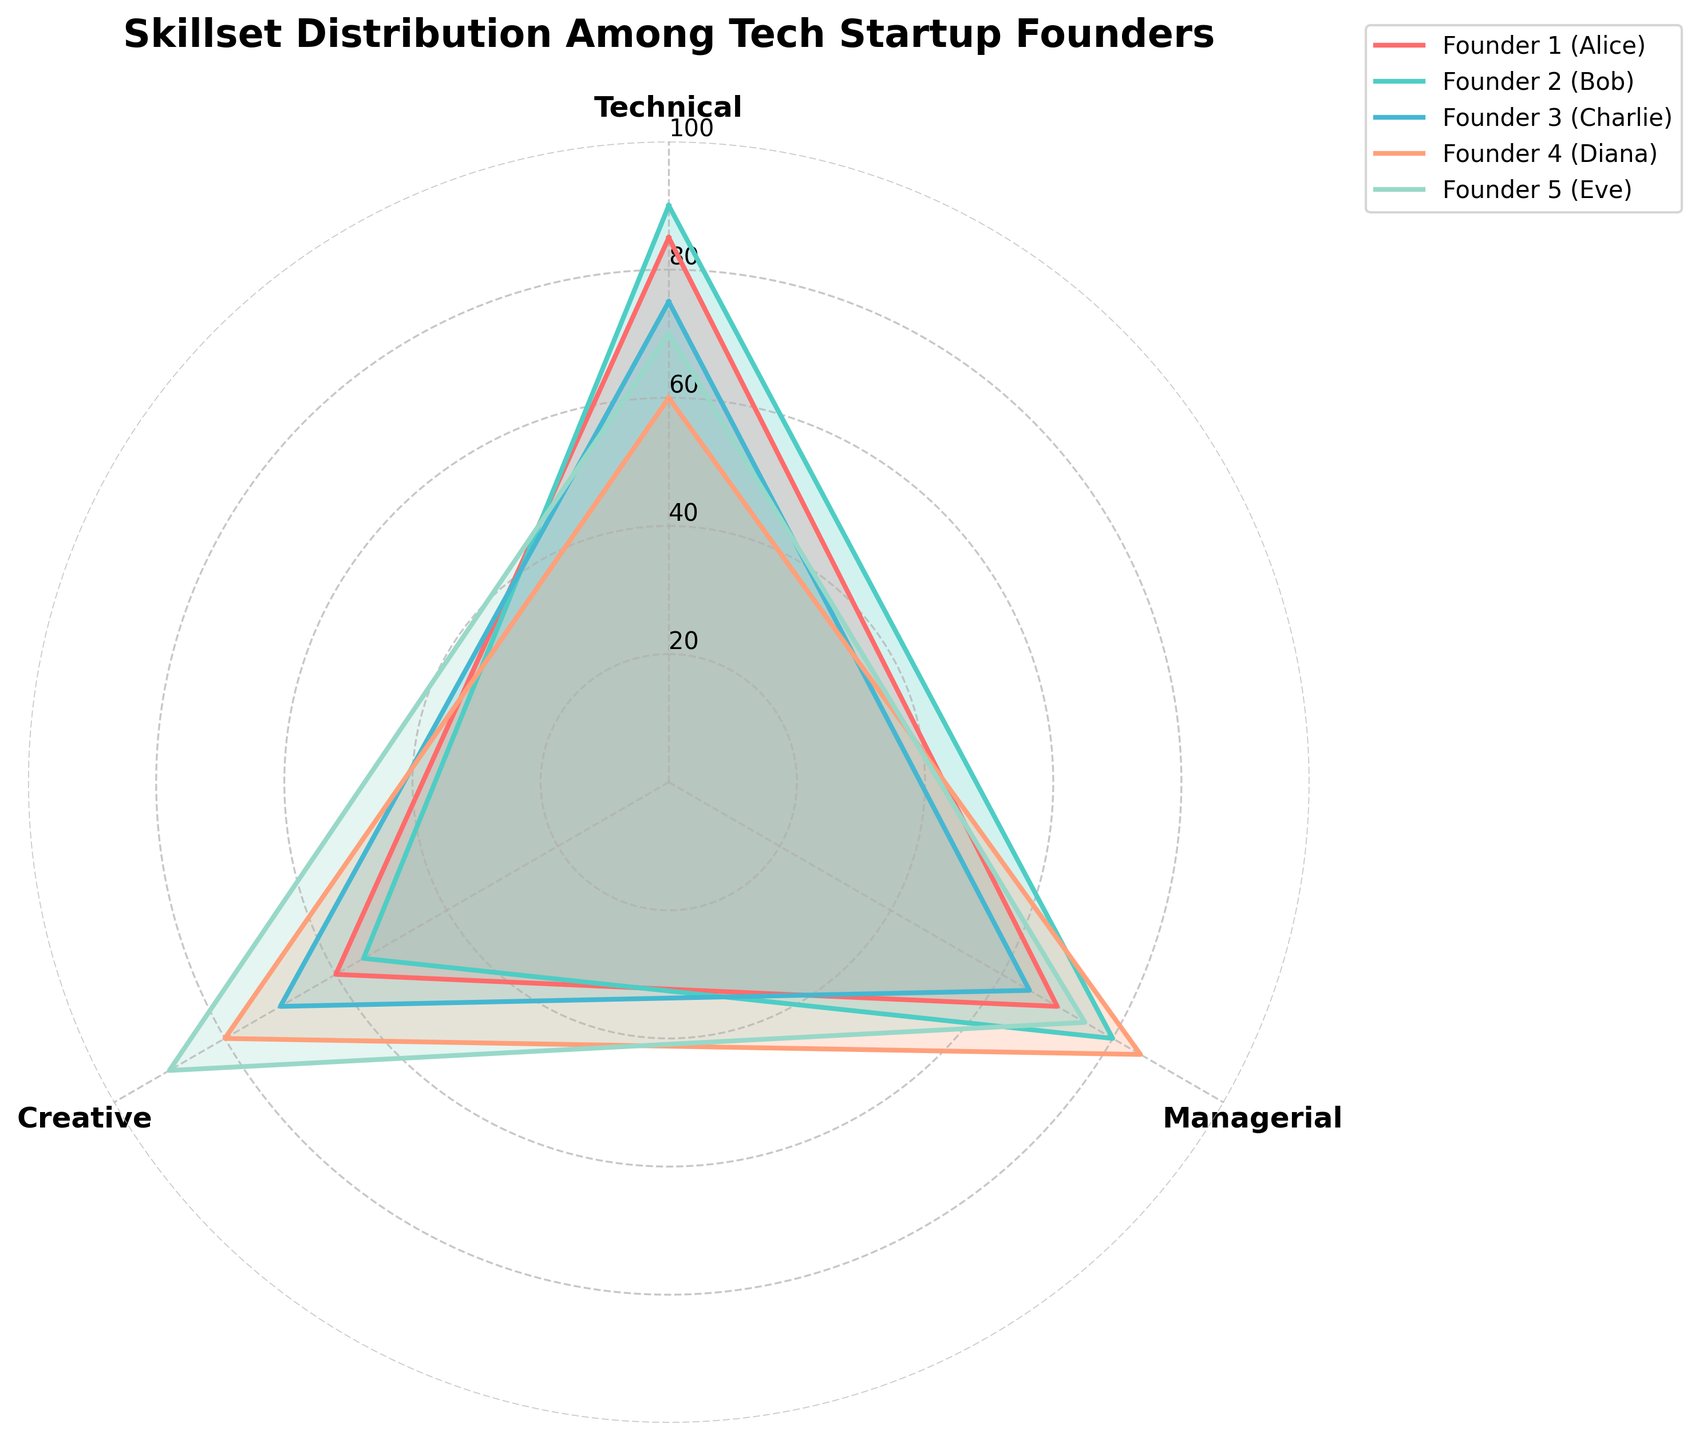What is the title of the radar chart? The title is usually prominently displayed at the top of the chart and serves as a summary of what the visualization is about. In this case, the title is "Skillset Distribution Among Tech Startup Founders".
Answer: Skillset Distribution Among Tech Startup Founders Which founder has the highest technical skill? By comparing the values in the "Technical" category for each founder, we find that Bob has the highest technical score with a value of 90.
Answer: Bob How many categories are being compared in the radar chart? The radar chart compares the founders' skill sets in three categories, which can be identified as Technical, Managerial, and Creative.
Answer: 3 Which founder has the highest managerial skills? By looking at the Managerial scores for each founder, Diana has the highest score with a value of 85.
Answer: Diana What is the average technical skill score of all founders? To find the average, sum the technical scores of all founders (85 + 90 + 75 + 60 + 70) = 380, then divide by the number of founders (5). The average is 380 / 5 = 76.
Answer: 76 Which founder has the highest average skill across all categories? Calculate the average skill score for each founder across all categories: 
Alice = (85 + 70 + 60) / 3 = 71.7, 
Bob = (90 + 80 + 55) / 3 = 75, 
Charlie = (75 + 65 + 70) / 3 = 70, 
Diana = (60 + 85 + 80) / 3 = 75, 
Eve = (70 + 75 + 90) / 3 = 78.3. 
Eve has the highest average skill score.
Answer: Eve Who has a greater creative skill, Alice or Eve? Comparing the Creative scores, Alice has 60, and Eve has 90. Thus, Eve has a greater creative skill.
Answer: Eve Which two founders have the closest managerial skill scores and what are their scores? By examining the Managerial scores, Alice (70) and Charlie (65) have the closest scores with a difference of 5.
Answer: Alice and Charlie, 70 and 65 Is there any founder whose skills are equally balanced across the three categories? For equally balanced skills, the scores in Technical, Managerial, and Creative would need to be equal or very close. By observing, no founder has exactly equal scores. The most balanced score belongs to Charlie (75, 65, 70).
Answer: No, the closest is Charlie Which founder has the lowest score in any category, and what is that score? By looking at all the categories, the lowest score is Bob's Creative skill, which is 55.
Answer: Bob, 55 